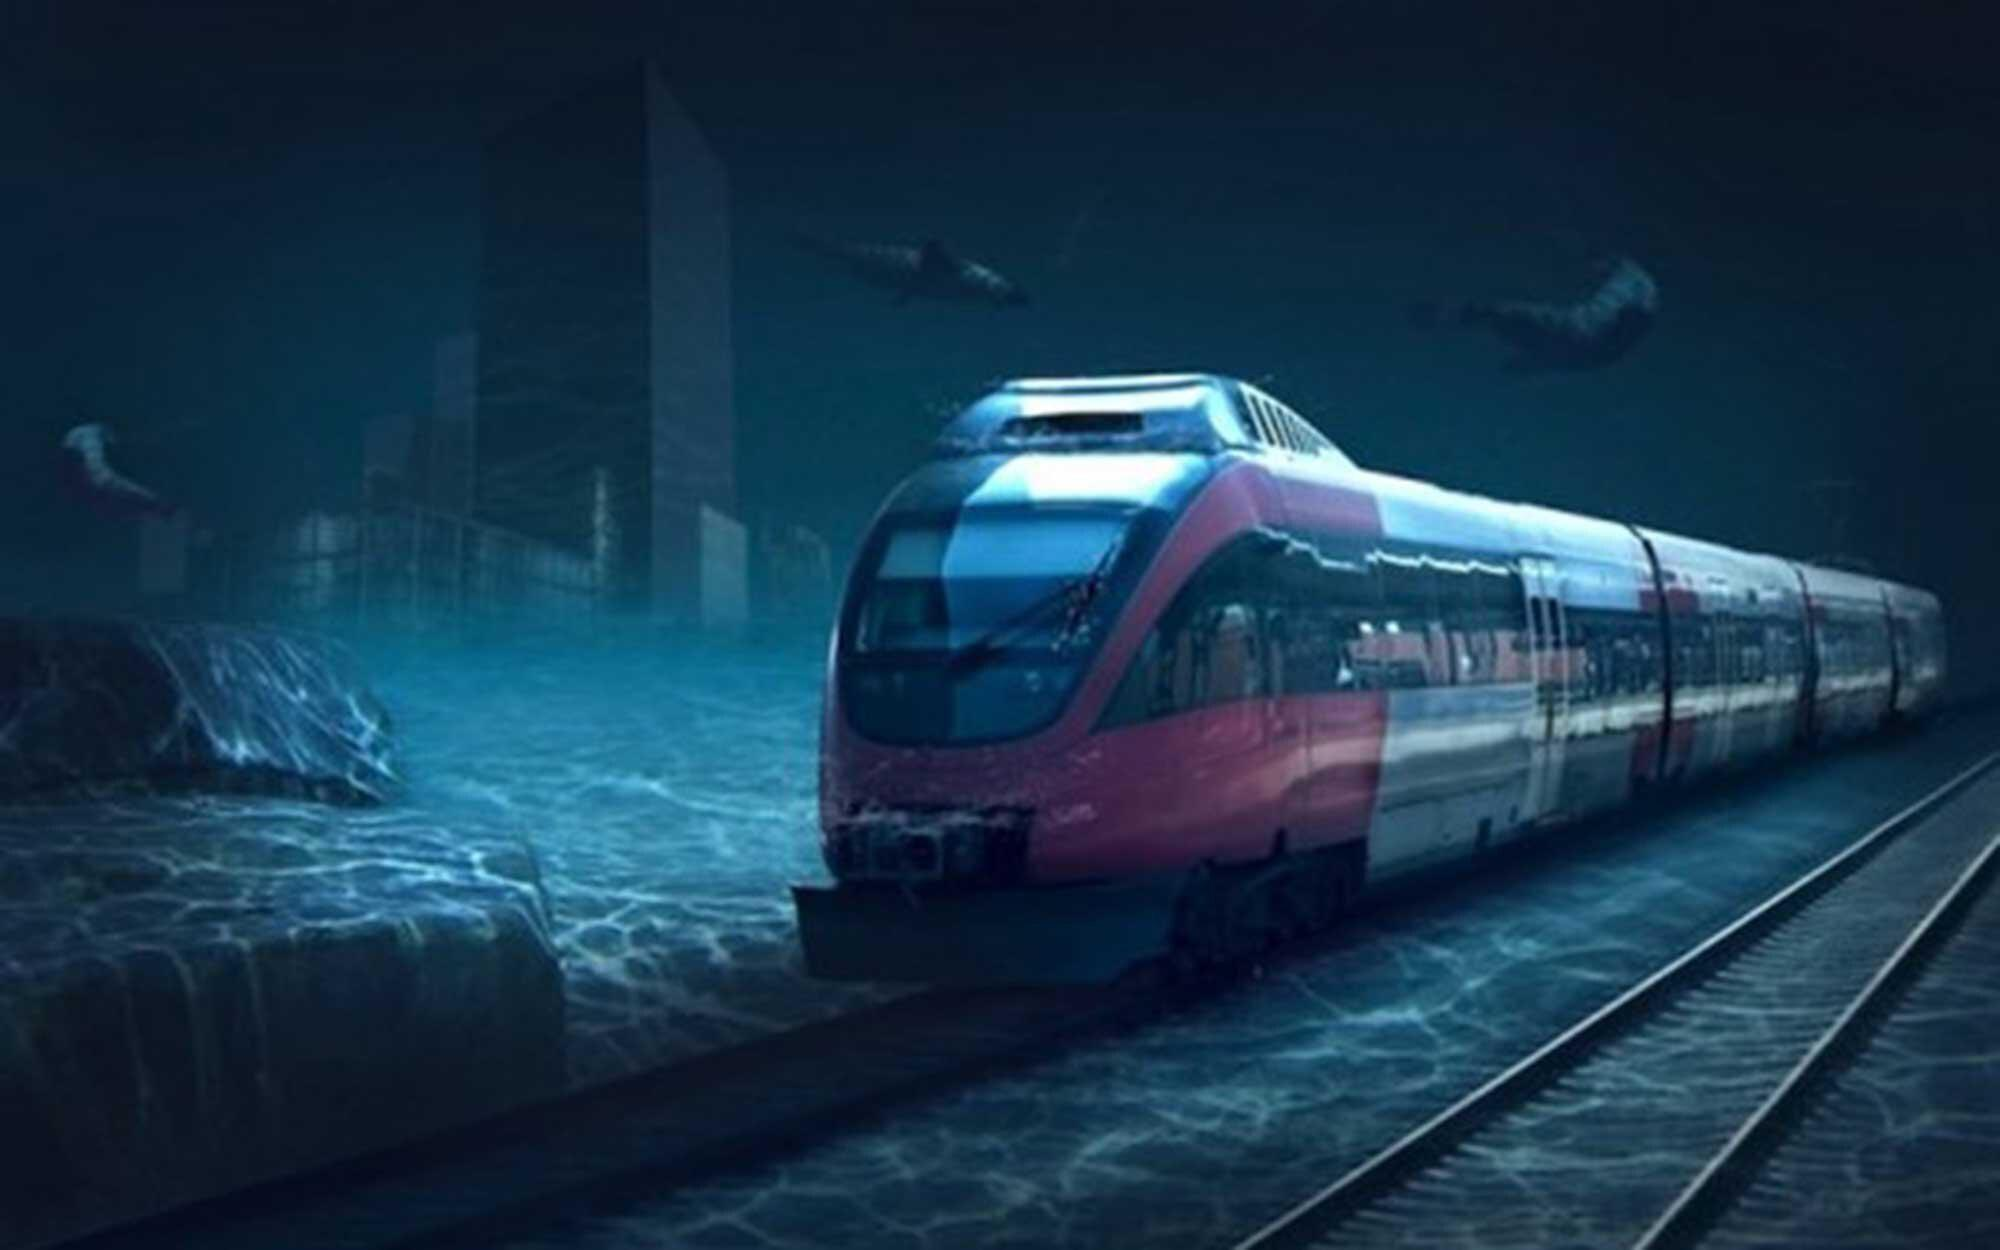Is there a train in the image? Yes, the image features a sleek, modern train gliding through what appears to be a submerged cityscape at dusk. The reflections in the water add a tranquil yet eerie atmosphere to the scene, and the presence of flying birds contrast with the submerged city, suggesting a juxtaposition between nature and an altered urban environment. 